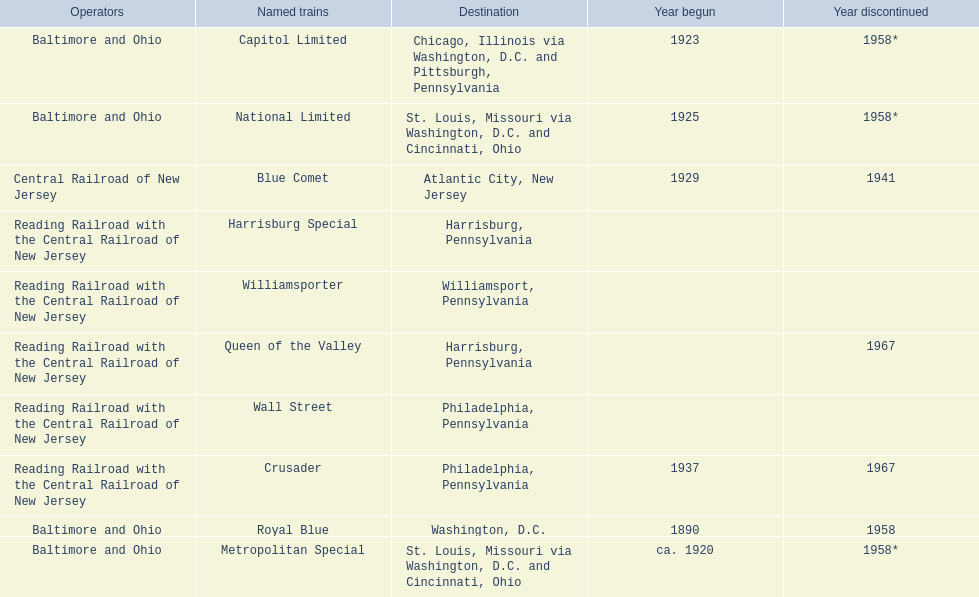What destinations are there? Chicago, Illinois via Washington, D.C. and Pittsburgh, Pennsylvania, St. Louis, Missouri via Washington, D.C. and Cincinnati, Ohio, St. Louis, Missouri via Washington, D.C. and Cincinnati, Ohio, Washington, D.C., Atlantic City, New Jersey, Philadelphia, Pennsylvania, Harrisburg, Pennsylvania, Harrisburg, Pennsylvania, Philadelphia, Pennsylvania, Williamsport, Pennsylvania. Which one is at the top of the list? Chicago, Illinois via Washington, D.C. and Pittsburgh, Pennsylvania. 